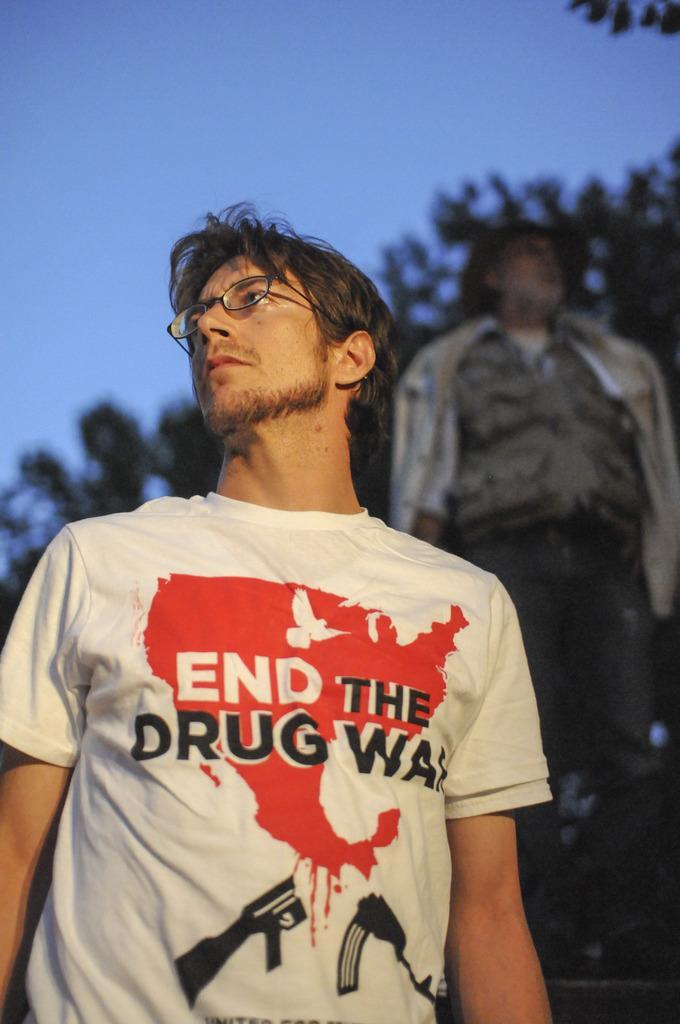In one or two sentences, can you explain what this image depicts? In this image we can see two persons standing. One person wearing white shirt and spectacles. In the background, we can see a group of trees and sky. 